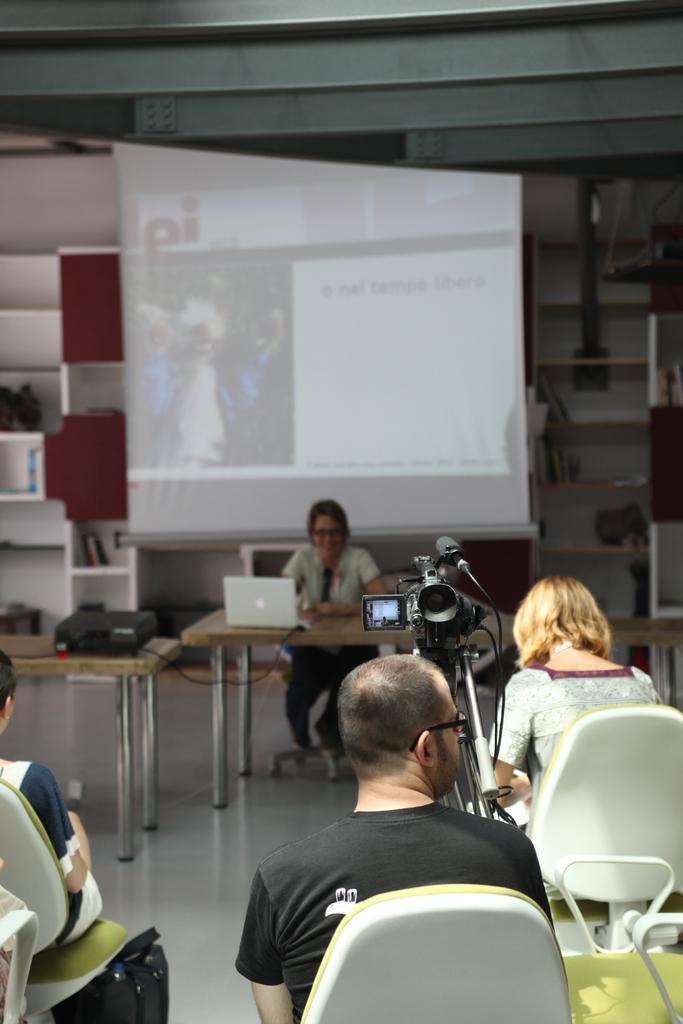Please provide a concise description of this image. In this image I can see few people are sitting on chairs, I can see he is wearing a specs. Here I can see a camera and on this table I can see a laptop. In the background I can see a projector's screen. 